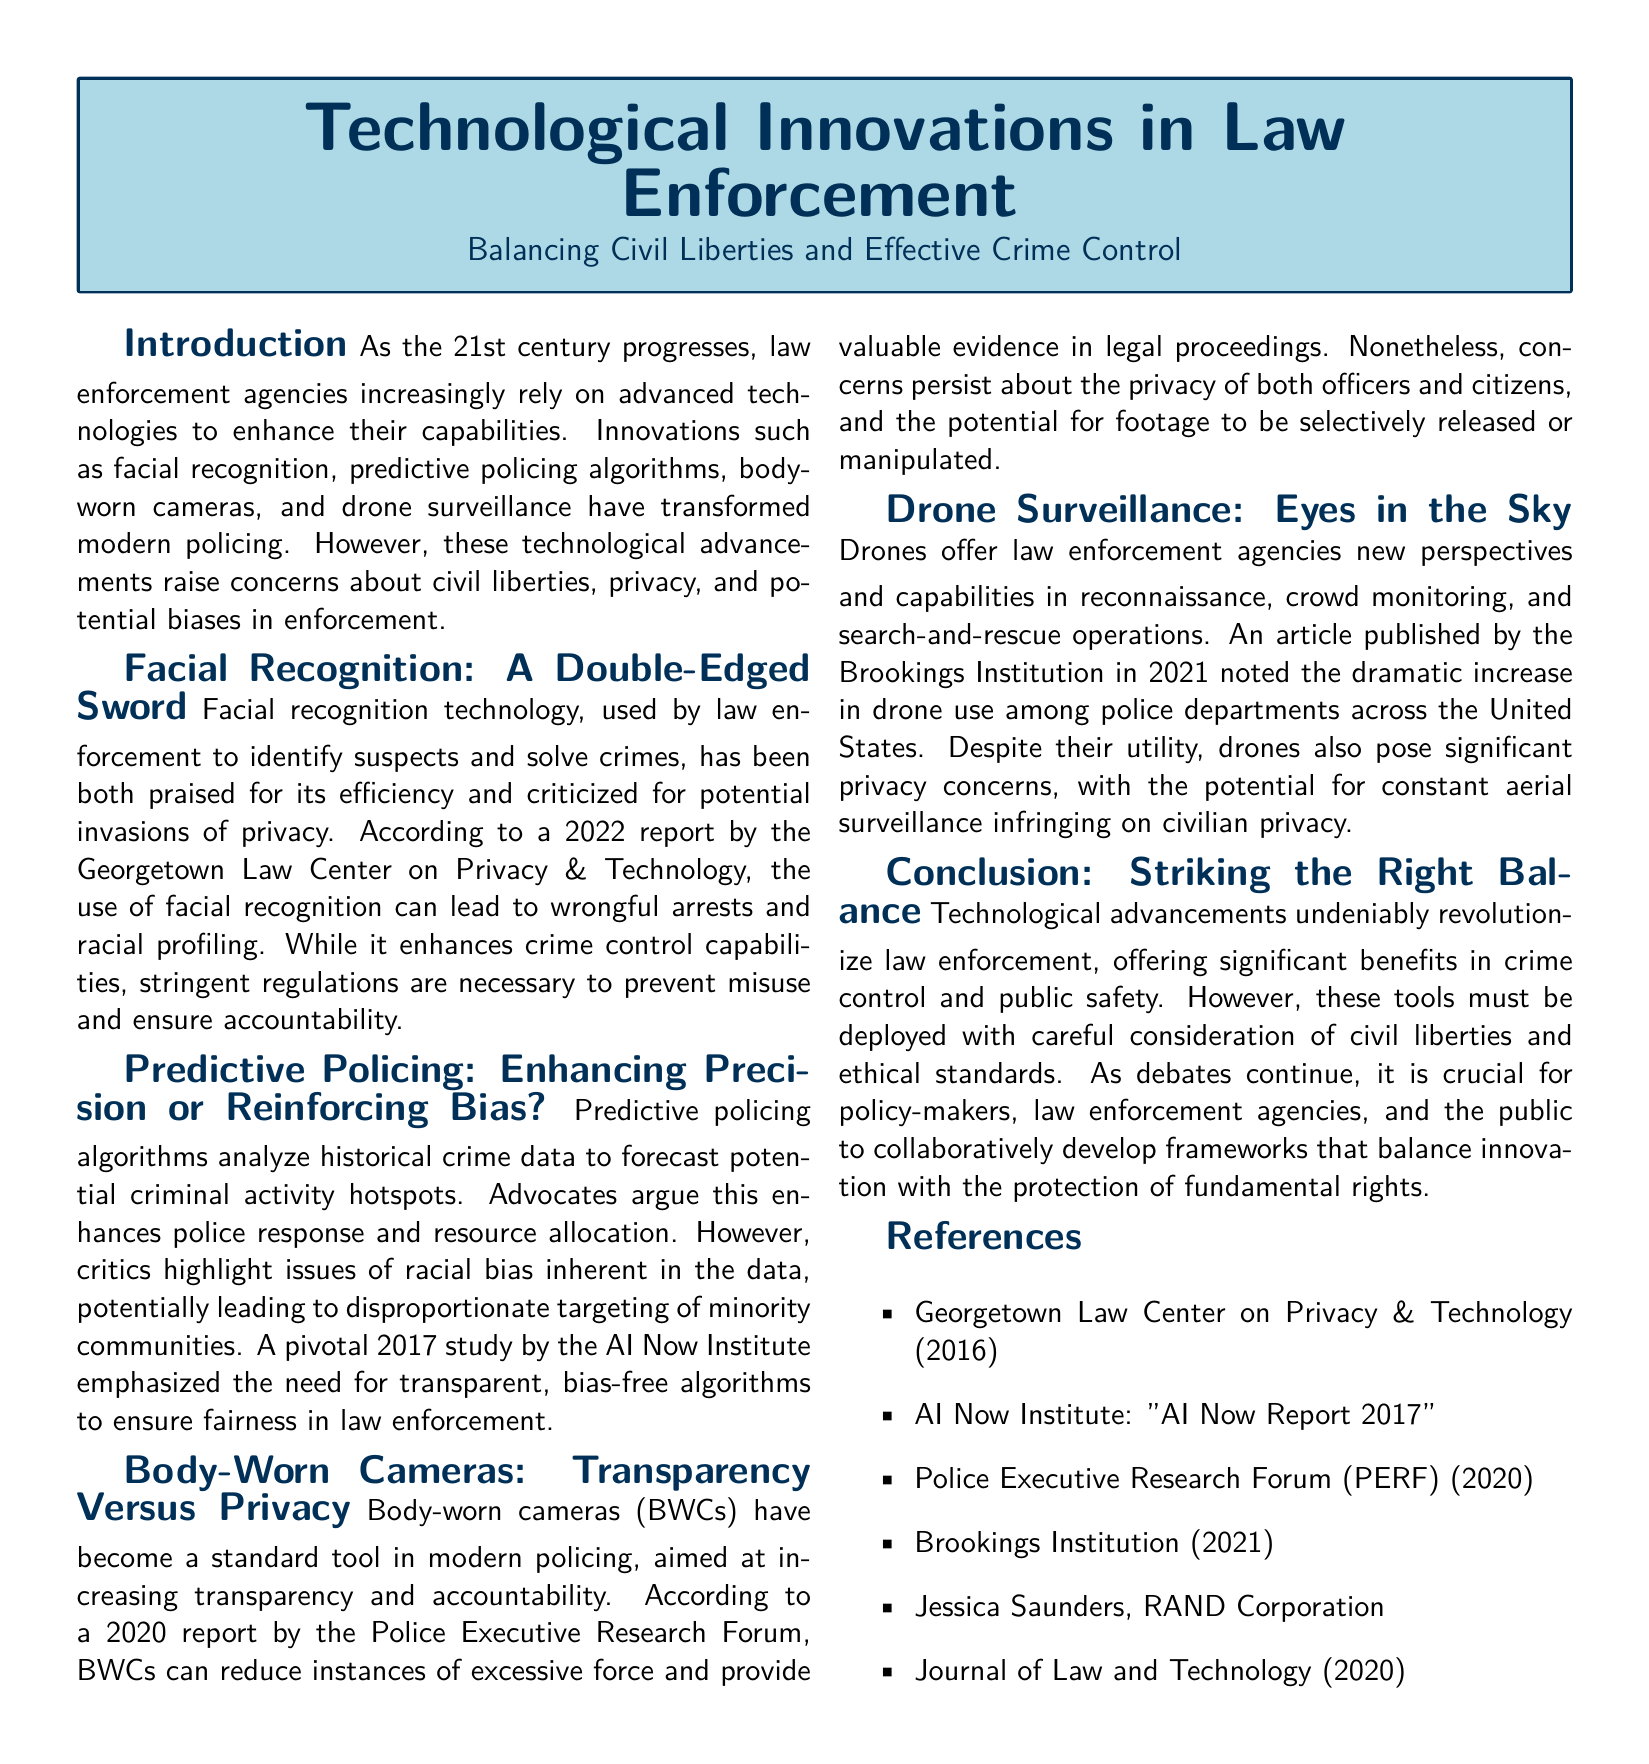What technology enhances police identification? The document specifically refers to facial recognition technology as enhancing police identification of suspects.
Answer: Facial recognition What study emphasized the need for bias-free algorithms? The AI Now Institute's 2017 study highlighted the importance of transparent, bias-free algorithms in predictive policing.
Answer: AI Now Institute: "AI Now Report 2017" What technology is aimed at increasing transparency in policing? Body-worn cameras (BWCs) are highlighted in the document as tools aimed at increasing transparency in law enforcement.
Answer: Body-worn cameras What significant concerns does drone surveillance raise? The primary concern noted in the document regarding drone surveillance is privacy infringement on civilians.
Answer: Privacy concerns What year did the Police Executive Research Forum release a report about body-worn cameras? The document states that the Police Executive Research Forum released a report in 2020 on body-worn cameras.
Answer: 2020 